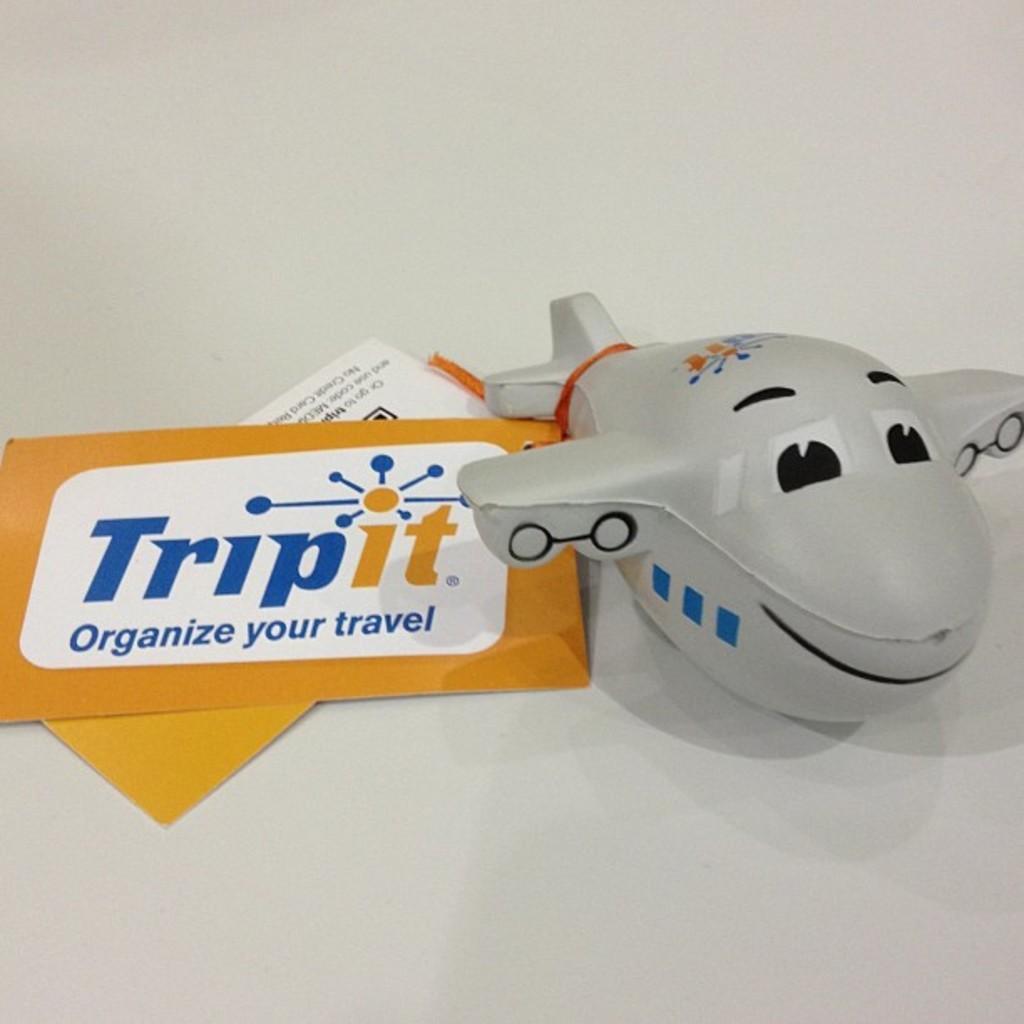Describe this image in one or two sentences. In this image I can see a aeroplane toy which is white and black in color on the white colored surface and I can see two papers which are orange and white in color. 